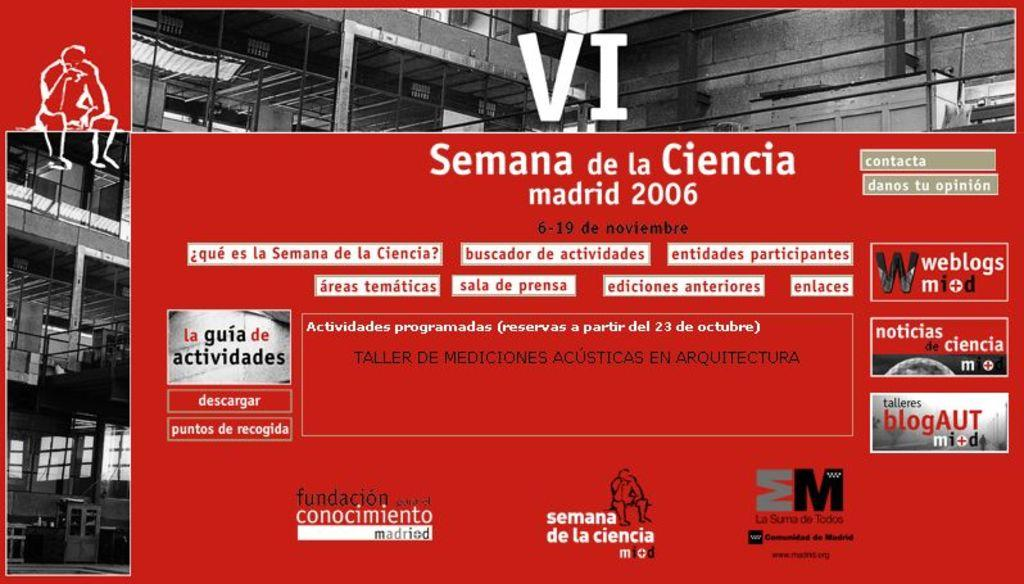<image>
Provide a brief description of the given image. A flyer for an event in Madrid in 2006 